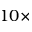Convert formula to latex. <formula><loc_0><loc_0><loc_500><loc_500>1 0 \times</formula> 